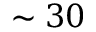<formula> <loc_0><loc_0><loc_500><loc_500>\sim 3 0</formula> 